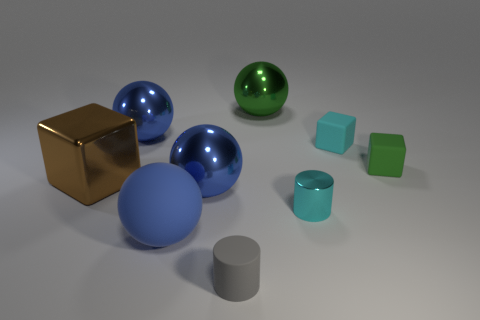How many objects are large blue metallic objects that are on the right side of the large matte thing or gray matte cylinders? 2 